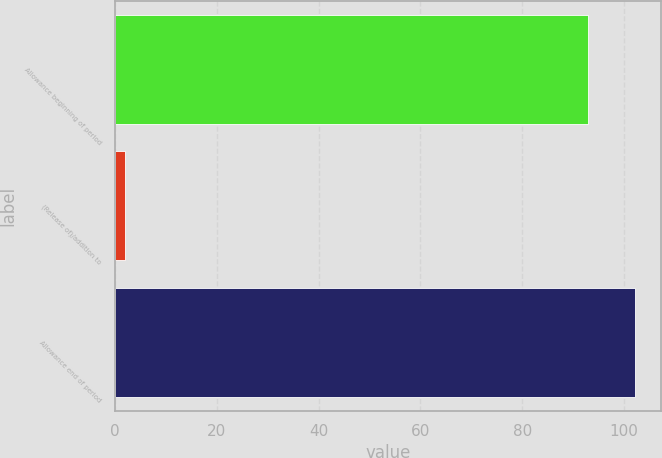Convert chart. <chart><loc_0><loc_0><loc_500><loc_500><bar_chart><fcel>Allowance beginning of period<fcel>(Release of)/addition to<fcel>Allowance end of period<nl><fcel>93<fcel>2<fcel>102.2<nl></chart> 